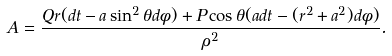<formula> <loc_0><loc_0><loc_500><loc_500>A = \frac { Q r ( d t - a \sin ^ { 2 } \theta d \phi ) + P \cos \theta ( a d t - ( r ^ { 2 } + a ^ { 2 } ) d \phi ) } { \rho ^ { 2 } } .</formula> 